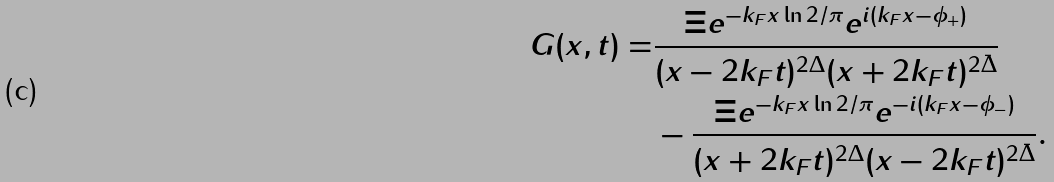<formula> <loc_0><loc_0><loc_500><loc_500>G ( x , t ) = & \frac { \Xi e ^ { - k _ { F } x \ln 2 / \pi } e ^ { i ( k _ { F } x - \phi _ { + } ) } } { ( x - 2 k _ { F } t ) ^ { 2 \Delta } ( x + 2 k _ { F } t ) ^ { 2 \bar { \Delta } } } \\ & - \frac { \Xi e ^ { - k _ { F } x \ln 2 / \pi } e ^ { - i ( k _ { F } x - \phi _ { - } ) } } { ( x + 2 k _ { F } t ) ^ { 2 \Delta } ( x - 2 k _ { F } t ) ^ { 2 \bar { \Delta } } } .</formula> 